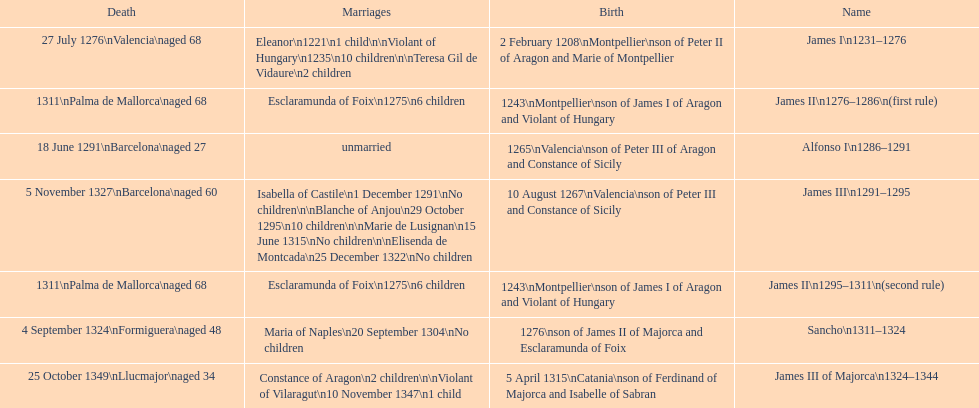Which monarch had the most marriages? James III 1291-1295. 